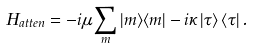Convert formula to latex. <formula><loc_0><loc_0><loc_500><loc_500>H _ { a t t e n } = - i \mu \sum _ { m } | m \rangle \langle m | - i \kappa \left | \tau \right \rangle \left \langle \tau \right | .</formula> 